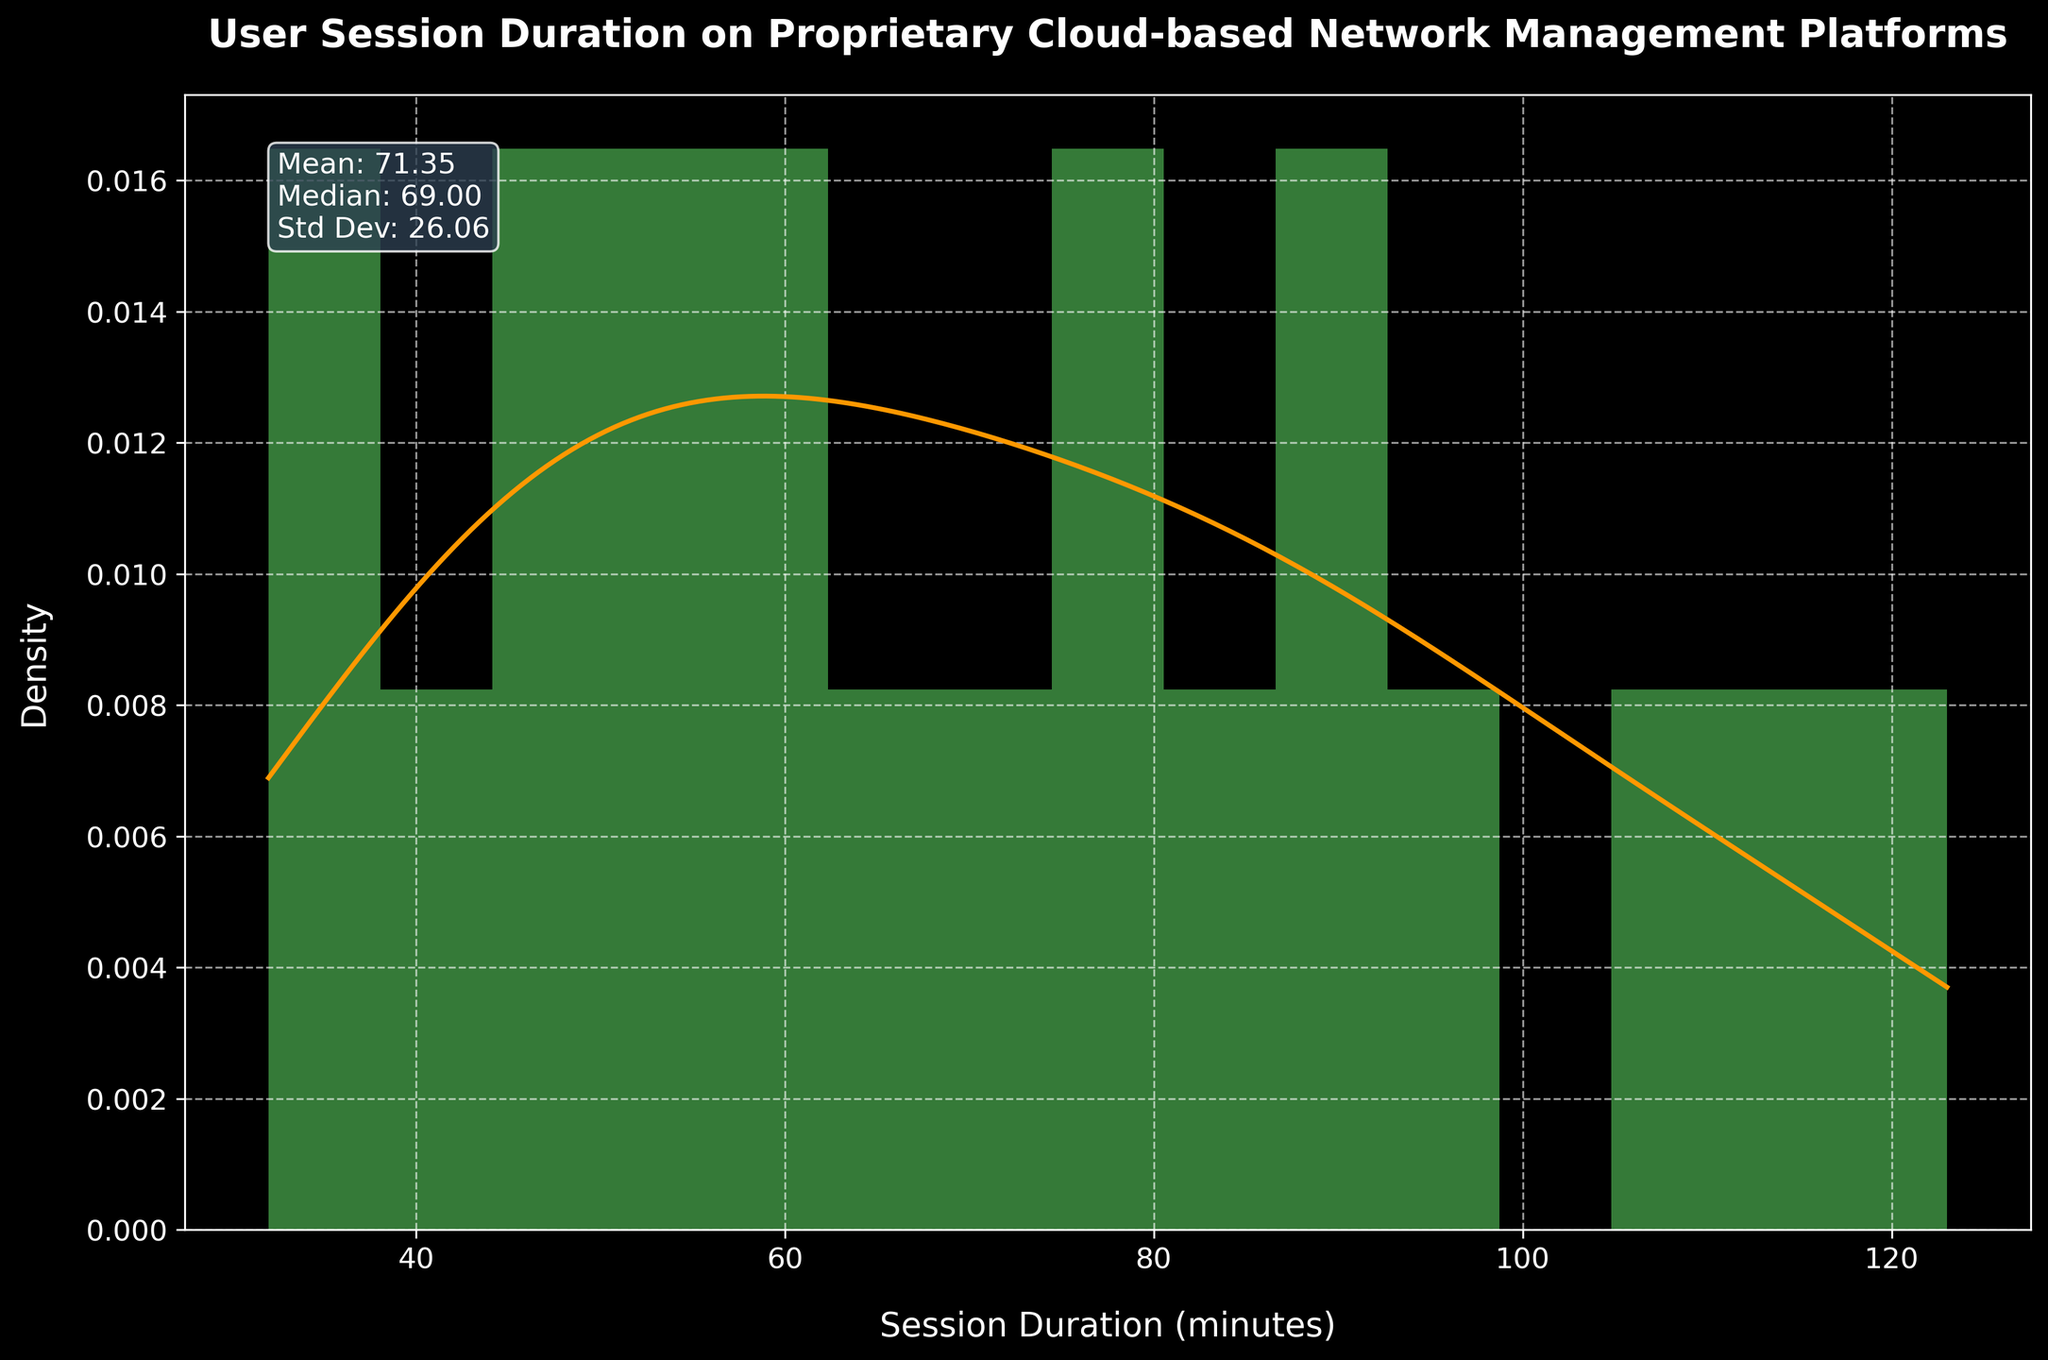What is the title of the figure? The title is usually located at the top of the figure and is meant to provide an at-a-glance understanding of what the figure is portraying.
Answer: User Session Duration on Proprietary Cloud-based Network Management Platforms What does the x-axis represent? The x-axis is labeled and represents the independent variable that we are measuring. In this figure, it represents the duration of user sessions in minutes.
Answer: Session Duration (minutes) What color is the histogram plotted in? The color of the histogram can be identified from its visual appearance. In this figure, the histogram is plotted in green.
Answer: Green What is the mean session duration? The mean session duration is found in the text box with statistics in the figure.
Answer: 70.5 What is the median session duration? The median session duration is also in the text box with statistics in the figure.
Answer: 67.0 How does the height of the density curve compare at the leftmost and rightmost part of the histogram? To compare the height, look at the density curve's height at both the left end (near the lowest session durations) and the right end (near the highest session durations) of the histogram. The curve tends to be lower at both ends and higher in the middle, indicating a higher density of session durations around the center of the distribution.
Answer: It is lower at both ends Which session duration has the highest density according to the KDE curve? Examine the highest point on the KDE curve, which represents the session duration with the highest density. The KDE peak usually indicates this duration.
Answer: Around 65-70 minutes Is the session duration distribution skewed and, if so, in which direction? To determine skewness, look at the KDE curve and histogram. If the tail is longer on the right side, it indicates right skewness and vice versa. In this figure, the curve and histogram indicate a slight right skew.
Answer: Slightly right-skewed What is the standard deviation of the session durations? The standard deviation is found in the text box with statistics in the figure. Standard deviation measures the amount of variation or dispersion of a set of values.
Answer: 26.9 